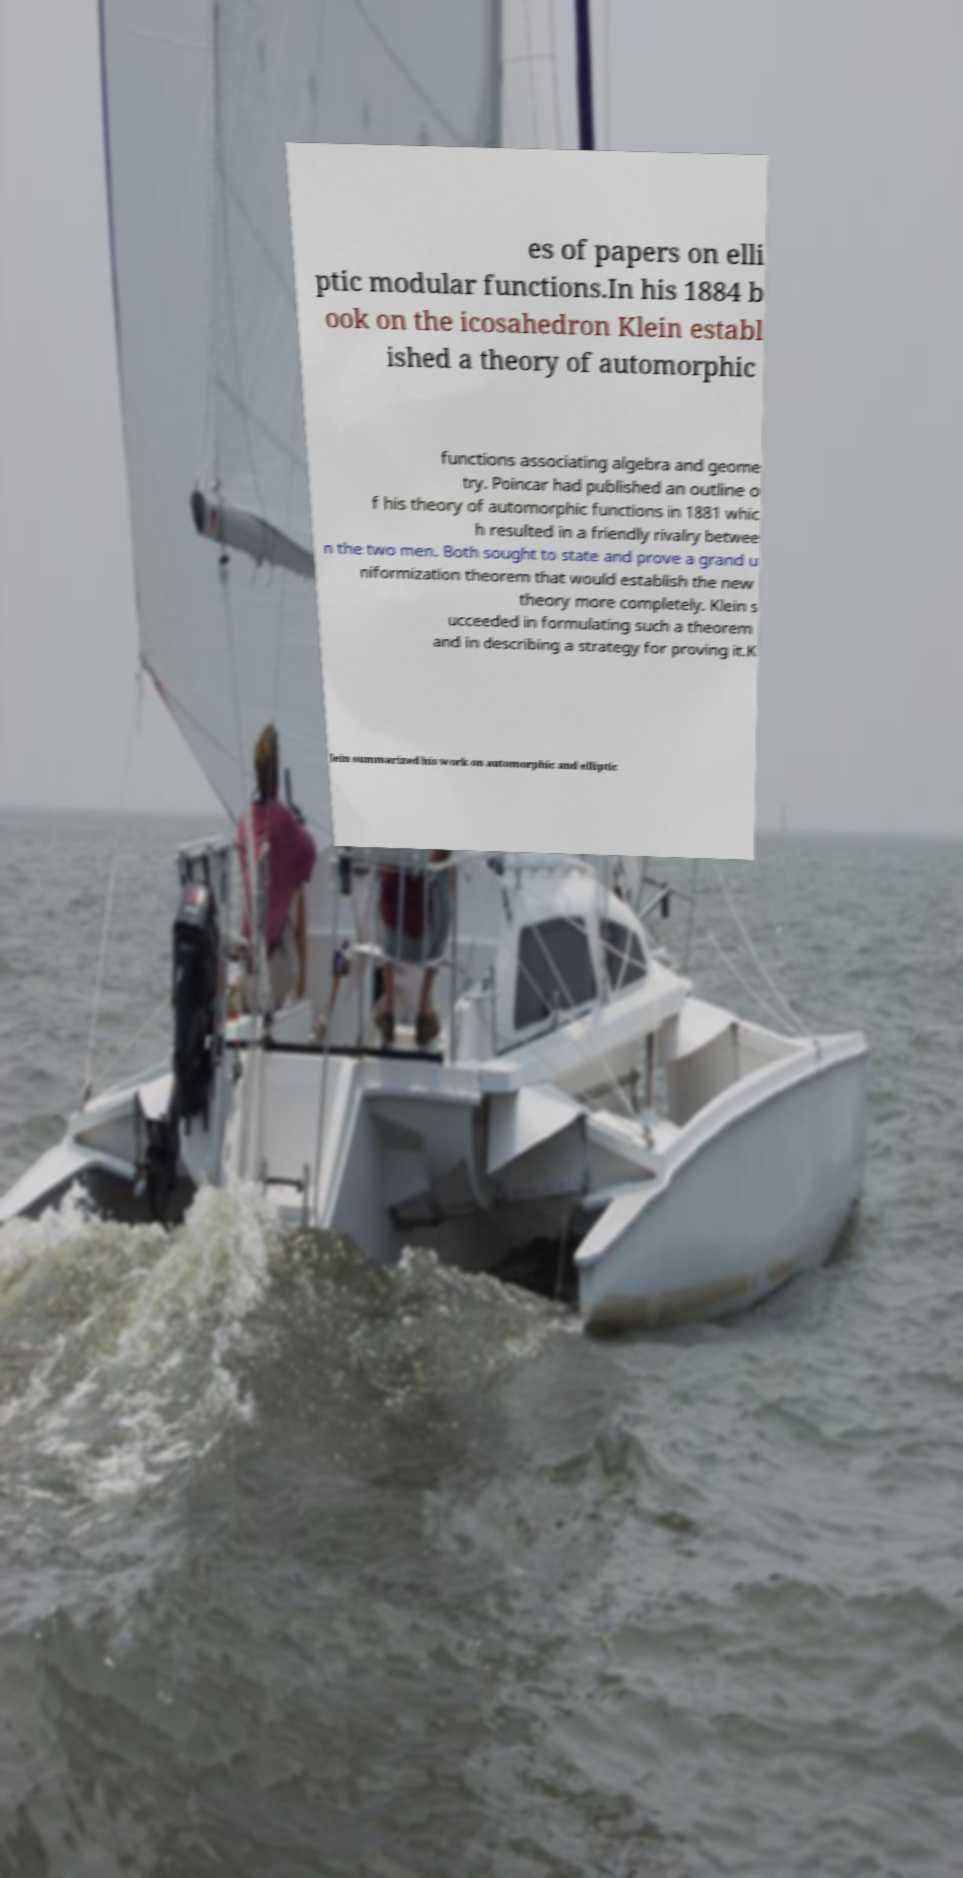Please read and relay the text visible in this image. What does it say? es of papers on elli ptic modular functions.In his 1884 b ook on the icosahedron Klein establ ished a theory of automorphic functions associating algebra and geome try. Poincar had published an outline o f his theory of automorphic functions in 1881 whic h resulted in a friendly rivalry betwee n the two men. Both sought to state and prove a grand u niformization theorem that would establish the new theory more completely. Klein s ucceeded in formulating such a theorem and in describing a strategy for proving it.K lein summarized his work on automorphic and elliptic 